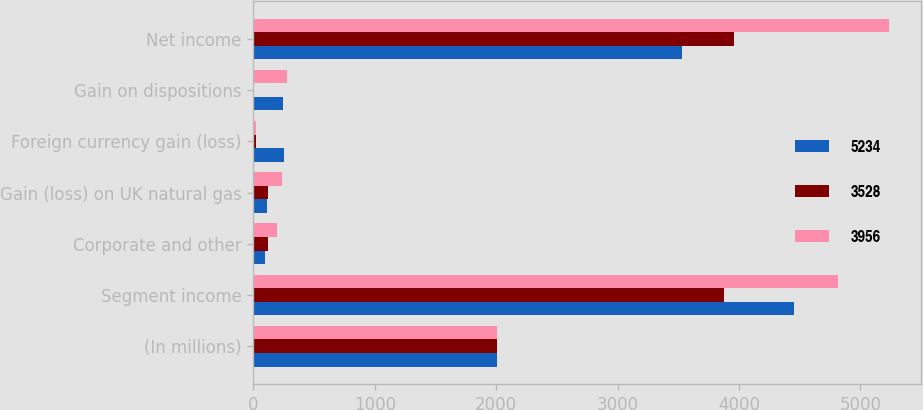Convert chart to OTSL. <chart><loc_0><loc_0><loc_500><loc_500><stacked_bar_chart><ecel><fcel>(In millions)<fcel>Segment income<fcel>Corporate and other<fcel>Gain (loss) on UK natural gas<fcel>Foreign currency gain (loss)<fcel>Gain on dispositions<fcel>Net income<nl><fcel>5234<fcel>2008<fcel>4454<fcel>93<fcel>111<fcel>252<fcel>241<fcel>3528<nl><fcel>3528<fcel>2007<fcel>3875<fcel>122<fcel>118<fcel>18<fcel>8<fcel>3956<nl><fcel>3956<fcel>2006<fcel>4814<fcel>190<fcel>232<fcel>22<fcel>274<fcel>5234<nl></chart> 